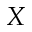Convert formula to latex. <formula><loc_0><loc_0><loc_500><loc_500>X</formula> 